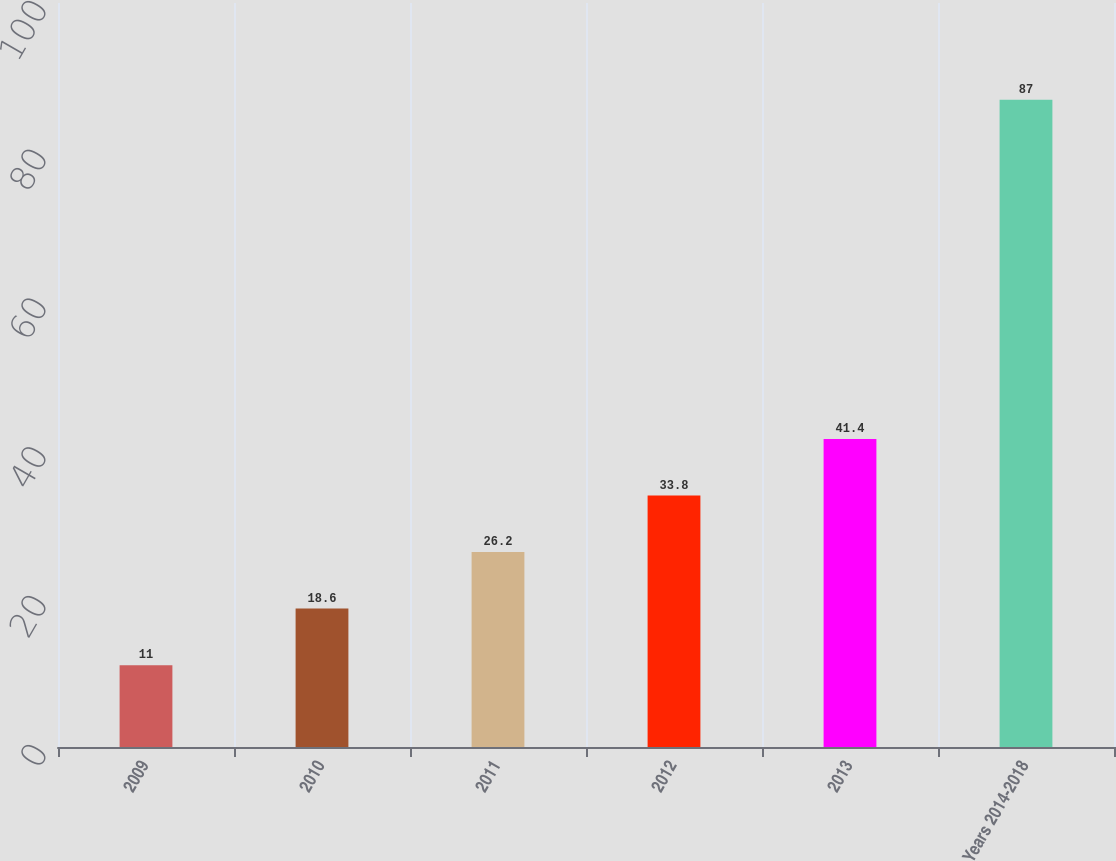Convert chart to OTSL. <chart><loc_0><loc_0><loc_500><loc_500><bar_chart><fcel>2009<fcel>2010<fcel>2011<fcel>2012<fcel>2013<fcel>Years 2014-2018<nl><fcel>11<fcel>18.6<fcel>26.2<fcel>33.8<fcel>41.4<fcel>87<nl></chart> 